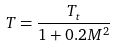Convert formula to latex. <formula><loc_0><loc_0><loc_500><loc_500>T = \frac { T _ { t } } { 1 + 0 . 2 M ^ { 2 } }</formula> 